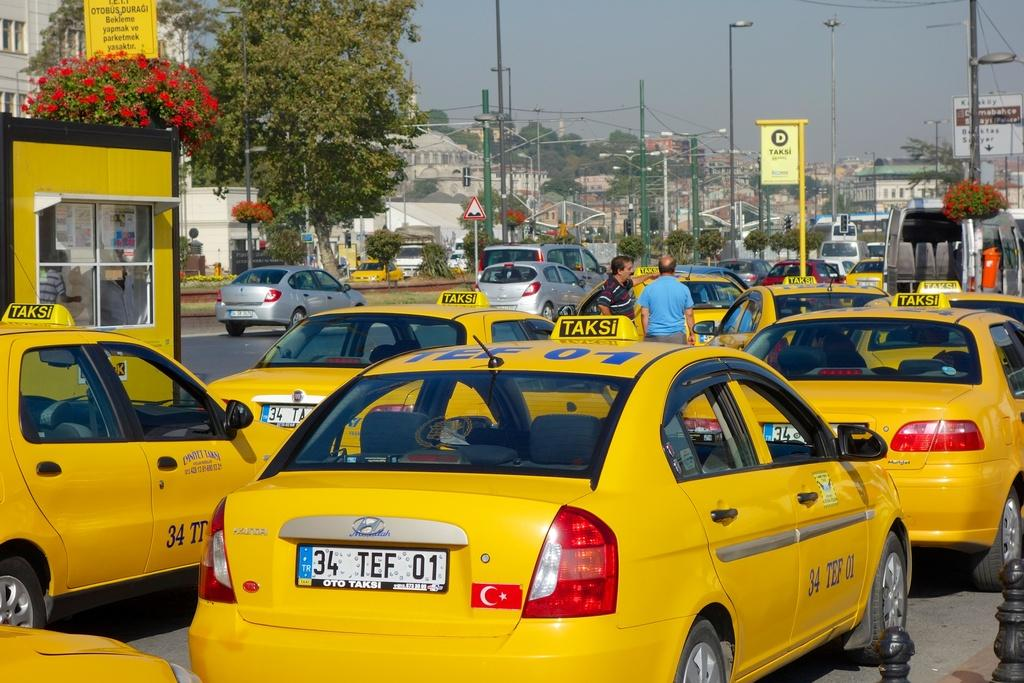<image>
Summarize the visual content of the image. A group of yellow taxi cab cars with tag number 34 TEF 01 on tag. 